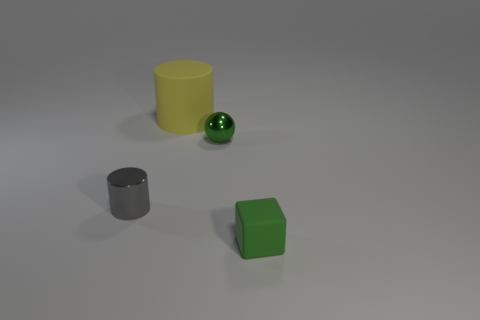Add 3 shiny cylinders. How many objects exist? 7 Subtract 1 green balls. How many objects are left? 3 Subtract 1 spheres. How many spheres are left? 0 Subtract all blue balls. Subtract all red cylinders. How many balls are left? 1 Subtract all blue balls. How many yellow cylinders are left? 1 Subtract all balls. Subtract all small metal cylinders. How many objects are left? 2 Add 4 yellow cylinders. How many yellow cylinders are left? 5 Add 2 big metal blocks. How many big metal blocks exist? 2 